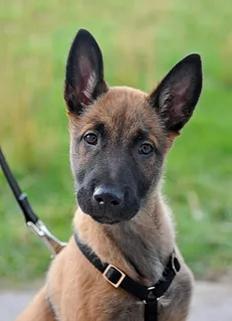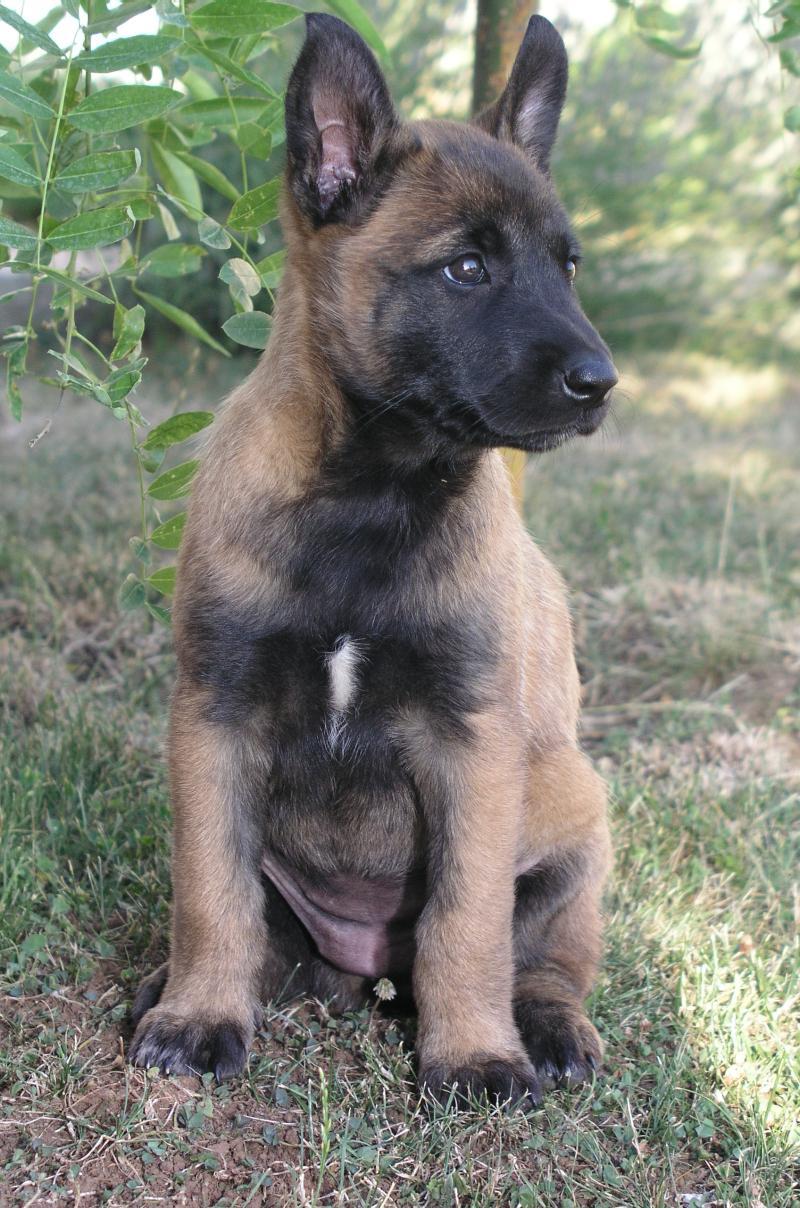The first image is the image on the left, the second image is the image on the right. Given the left and right images, does the statement "The dog in the left image is attached to a leash." hold true? Answer yes or no. Yes. The first image is the image on the left, the second image is the image on the right. For the images shown, is this caption "At least one dog is sitting in the grass." true? Answer yes or no. Yes. 